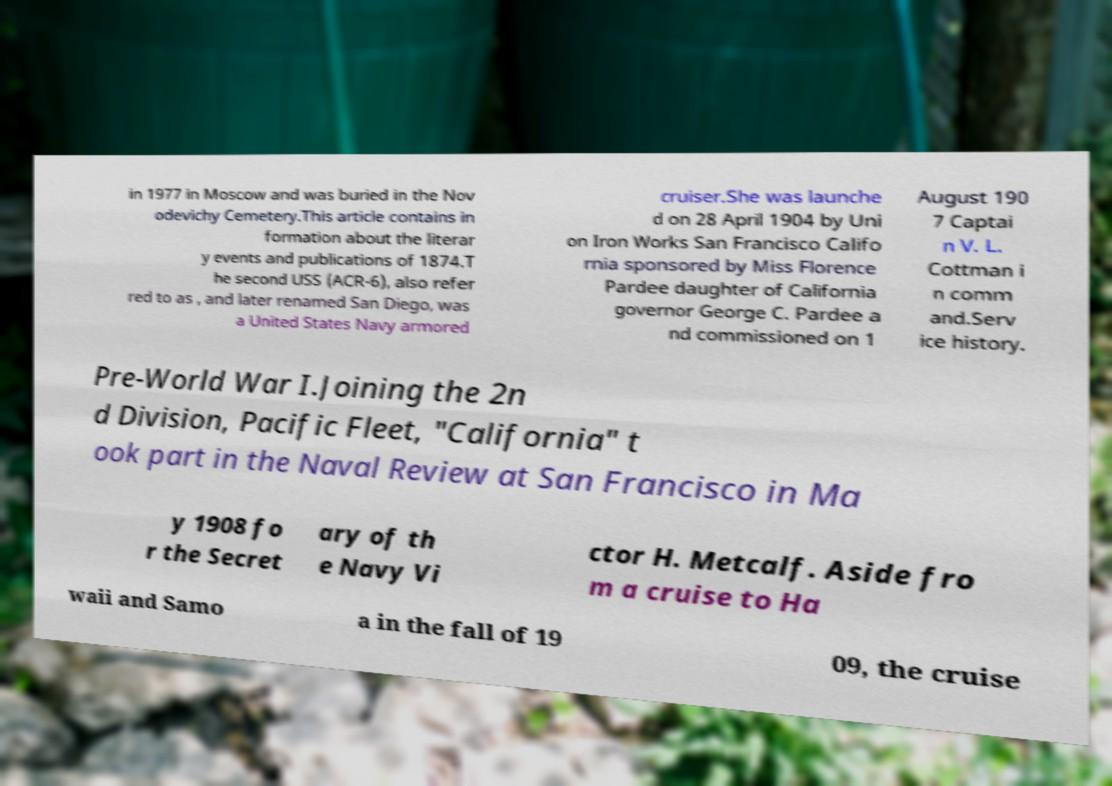I need the written content from this picture converted into text. Can you do that? in 1977 in Moscow and was buried in the Nov odevichy Cemetery.This article contains in formation about the literar y events and publications of 1874.T he second USS (ACR-6), also refer red to as , and later renamed San Diego, was a United States Navy armored cruiser.She was launche d on 28 April 1904 by Uni on Iron Works San Francisco Califo rnia sponsored by Miss Florence Pardee daughter of California governor George C. Pardee a nd commissioned on 1 August 190 7 Captai n V. L. Cottman i n comm and.Serv ice history. Pre-World War I.Joining the 2n d Division, Pacific Fleet, "California" t ook part in the Naval Review at San Francisco in Ma y 1908 fo r the Secret ary of th e Navy Vi ctor H. Metcalf. Aside fro m a cruise to Ha waii and Samo a in the fall of 19 09, the cruise 